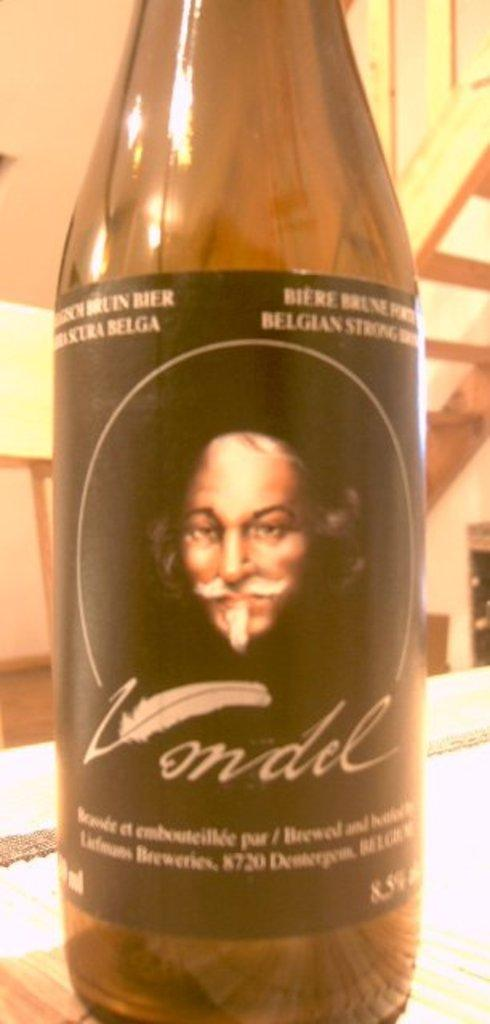<image>
Create a compact narrative representing the image presented. Bottle of Vondel sitting on a shelf in a large room. 